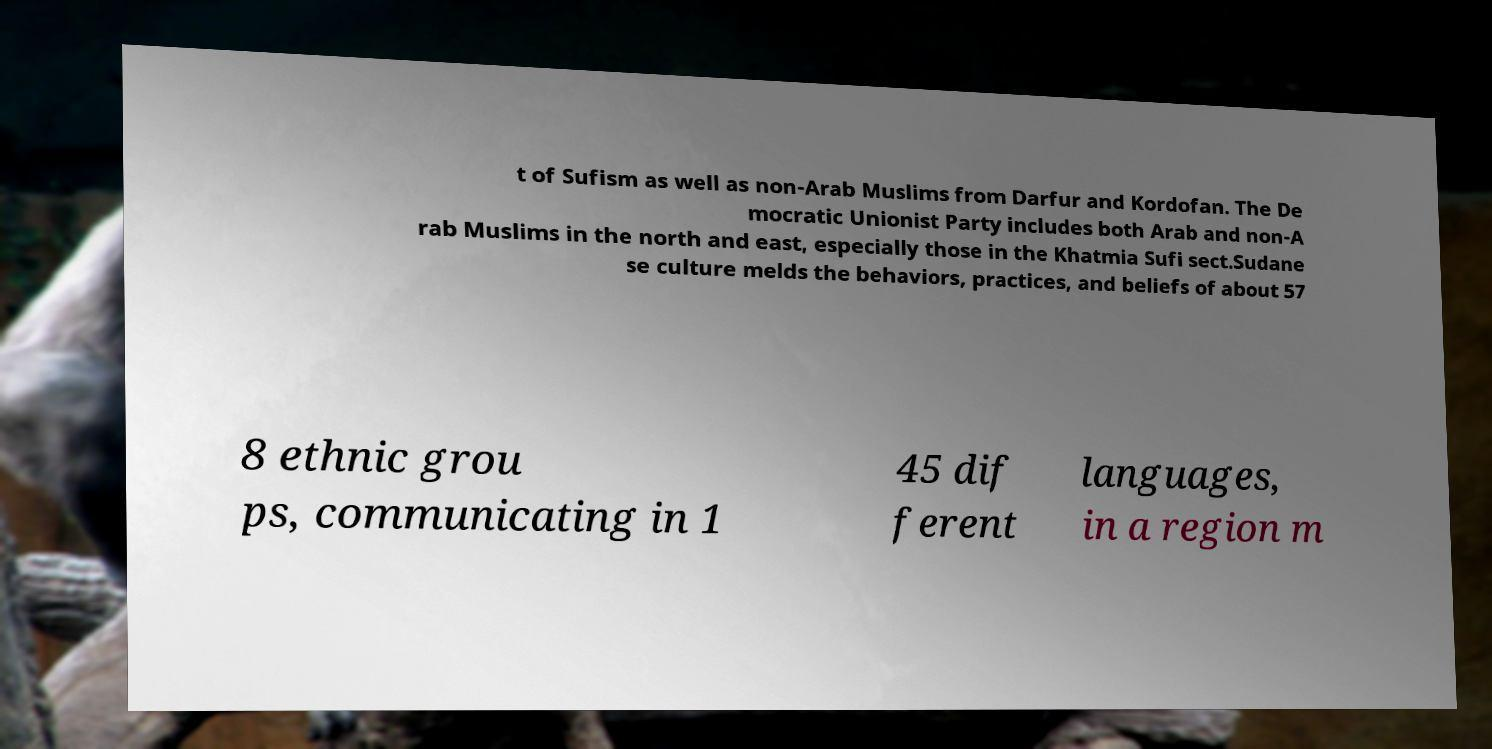Please read and relay the text visible in this image. What does it say? t of Sufism as well as non-Arab Muslims from Darfur and Kordofan. The De mocratic Unionist Party includes both Arab and non-A rab Muslims in the north and east, especially those in the Khatmia Sufi sect.Sudane se culture melds the behaviors, practices, and beliefs of about 57 8 ethnic grou ps, communicating in 1 45 dif ferent languages, in a region m 